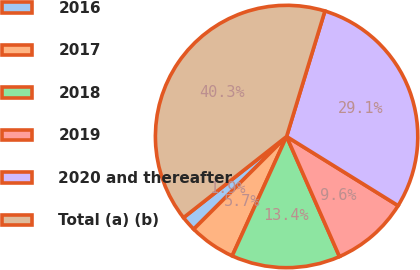Convert chart to OTSL. <chart><loc_0><loc_0><loc_500><loc_500><pie_chart><fcel>2016<fcel>2017<fcel>2018<fcel>2019<fcel>2020 and thereafter<fcel>Total (a) (b)<nl><fcel>1.87%<fcel>5.71%<fcel>13.41%<fcel>9.56%<fcel>29.12%<fcel>40.33%<nl></chart> 